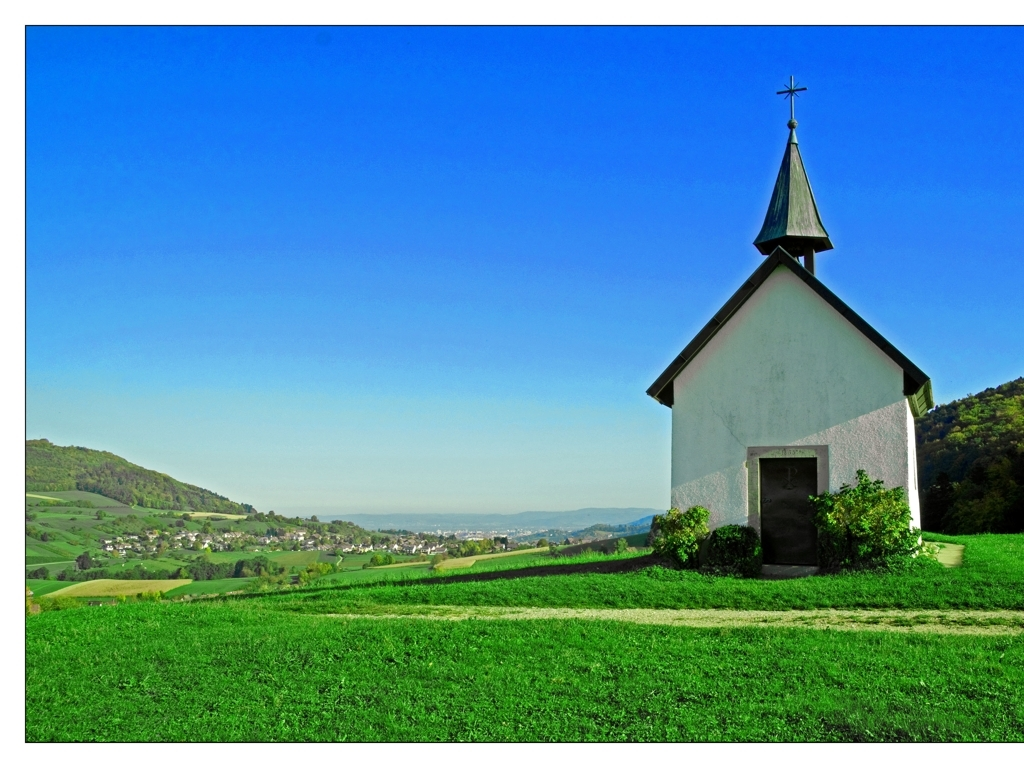What kind of geographical setting is the chapel located in? The chapel is set amidst a picturesque landscape, likely rural given the undulating hills and patches of forest in the distance. It's surrounded by well-maintained grass that suggests it may be a tended area, possibly part of a larger estate or community grounds. The settlement visible in the midground indicates the proximity of human habitation, perhaps a small village or a suburb. 